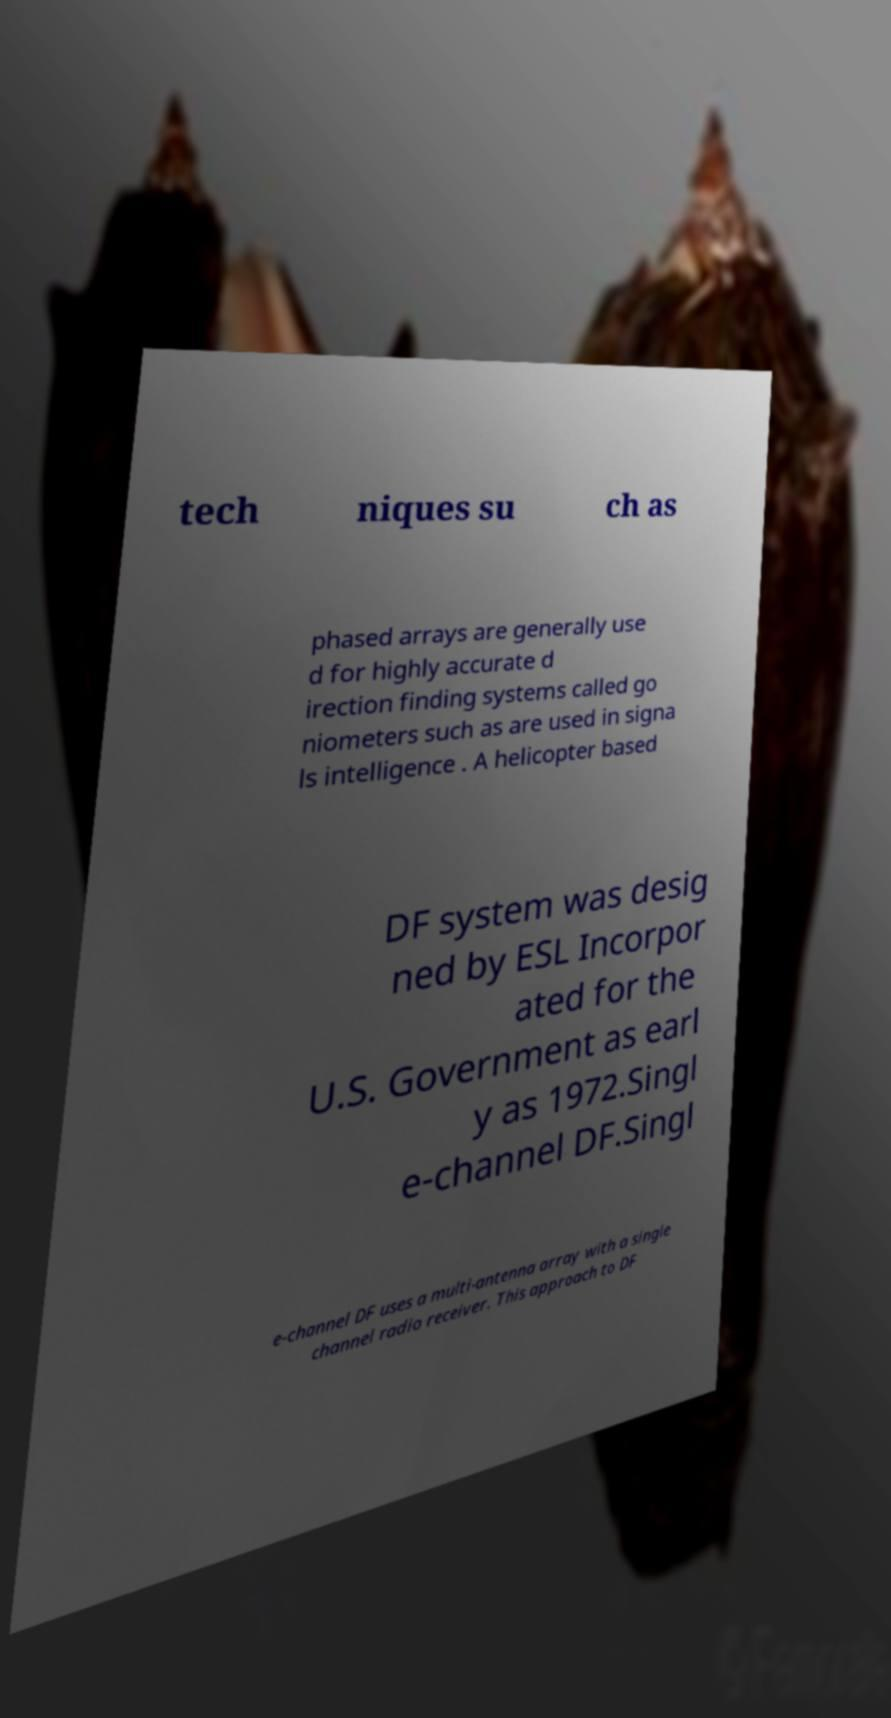Can you read and provide the text displayed in the image?This photo seems to have some interesting text. Can you extract and type it out for me? tech niques su ch as phased arrays are generally use d for highly accurate d irection finding systems called go niometers such as are used in signa ls intelligence . A helicopter based DF system was desig ned by ESL Incorpor ated for the U.S. Government as earl y as 1972.Singl e-channel DF.Singl e-channel DF uses a multi-antenna array with a single channel radio receiver. This approach to DF 